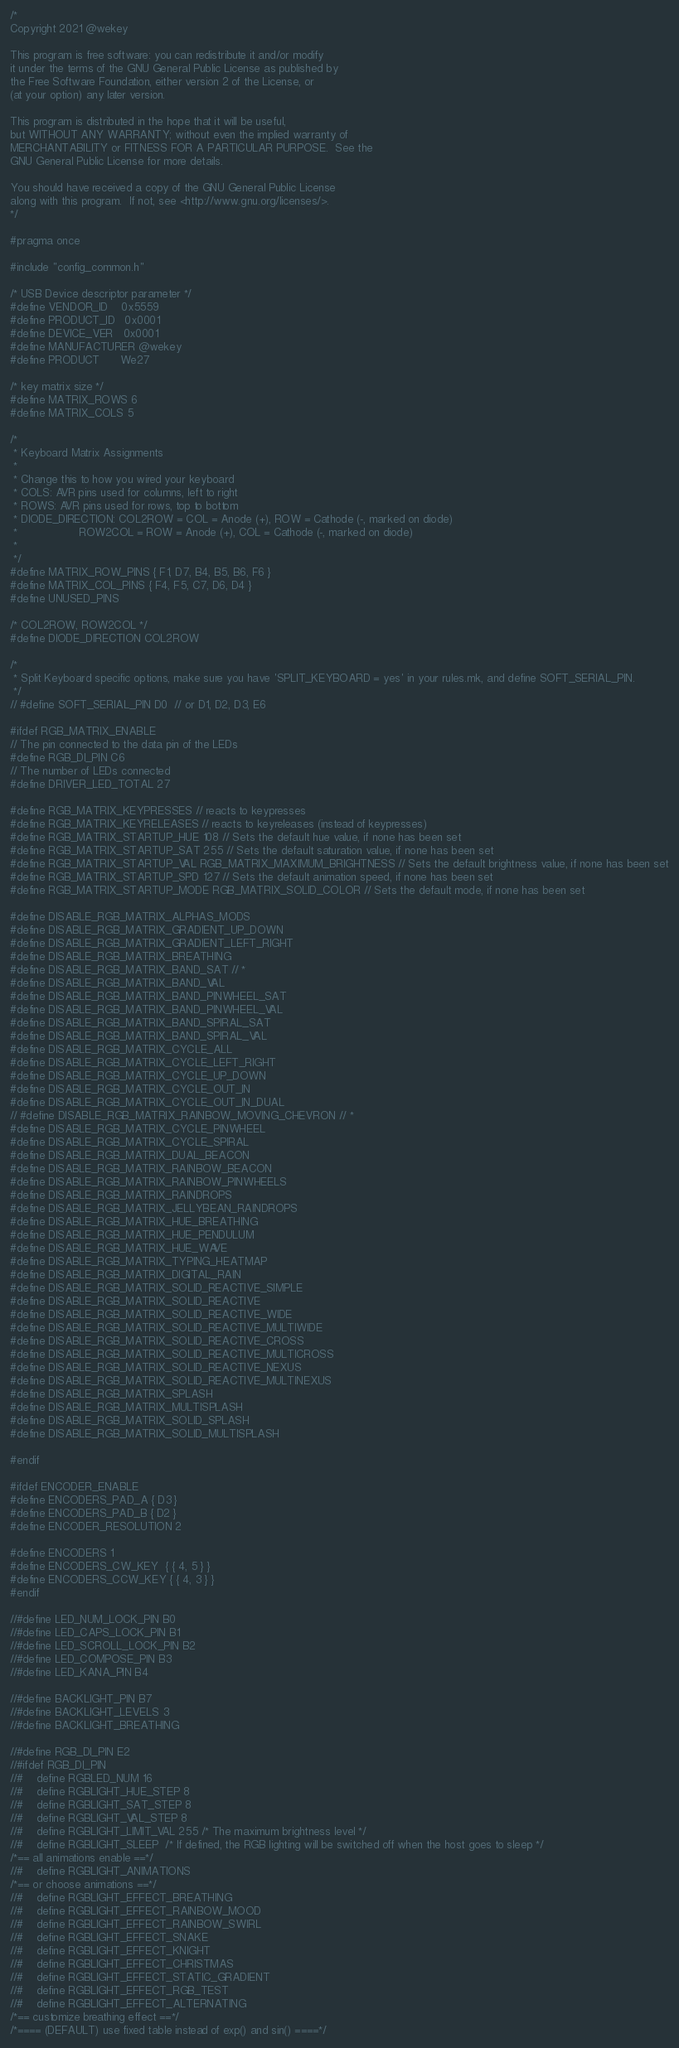<code> <loc_0><loc_0><loc_500><loc_500><_C_>/*
Copyright 2021 @wekey

This program is free software: you can redistribute it and/or modify
it under the terms of the GNU General Public License as published by
the Free Software Foundation, either version 2 of the License, or
(at your option) any later version.

This program is distributed in the hope that it will be useful,
but WITHOUT ANY WARRANTY; without even the implied warranty of
MERCHANTABILITY or FITNESS FOR A PARTICULAR PURPOSE.  See the
GNU General Public License for more details.

You should have received a copy of the GNU General Public License
along with this program.  If not, see <http://www.gnu.org/licenses/>.
*/

#pragma once

#include "config_common.h"

/* USB Device descriptor parameter */
#define VENDOR_ID    0x5559
#define PRODUCT_ID   0x0001
#define DEVICE_VER   0x0001
#define MANUFACTURER @wekey
#define PRODUCT      We27

/* key matrix size */
#define MATRIX_ROWS 6
#define MATRIX_COLS 5

/*
 * Keyboard Matrix Assignments
 *
 * Change this to how you wired your keyboard
 * COLS: AVR pins used for columns, left to right
 * ROWS: AVR pins used for rows, top to bottom
 * DIODE_DIRECTION: COL2ROW = COL = Anode (+), ROW = Cathode (-, marked on diode)
 *                  ROW2COL = ROW = Anode (+), COL = Cathode (-, marked on diode)
 *
 */
#define MATRIX_ROW_PINS { F1, D7, B4, B5, B6, F6 }
#define MATRIX_COL_PINS { F4, F5, C7, D6, D4 }
#define UNUSED_PINS

/* COL2ROW, ROW2COL */
#define DIODE_DIRECTION COL2ROW

/*
 * Split Keyboard specific options, make sure you have 'SPLIT_KEYBOARD = yes' in your rules.mk, and define SOFT_SERIAL_PIN.
 */
// #define SOFT_SERIAL_PIN D0  // or D1, D2, D3, E6

#ifdef RGB_MATRIX_ENABLE
// The pin connected to the data pin of the LEDs
#define RGB_DI_PIN C6
// The number of LEDs connected
#define DRIVER_LED_TOTAL 27

#define RGB_MATRIX_KEYPRESSES // reacts to keypresses
#define RGB_MATRIX_KEYRELEASES // reacts to keyreleases (instead of keypresses)
#define RGB_MATRIX_STARTUP_HUE 108 // Sets the default hue value, if none has been set
#define RGB_MATRIX_STARTUP_SAT 255 // Sets the default saturation value, if none has been set
#define RGB_MATRIX_STARTUP_VAL RGB_MATRIX_MAXIMUM_BRIGHTNESS // Sets the default brightness value, if none has been set
#define RGB_MATRIX_STARTUP_SPD 127 // Sets the default animation speed, if none has been set
#define RGB_MATRIX_STARTUP_MODE RGB_MATRIX_SOLID_COLOR // Sets the default mode, if none has been set

#define DISABLE_RGB_MATRIX_ALPHAS_MODS
#define DISABLE_RGB_MATRIX_GRADIENT_UP_DOWN
#define DISABLE_RGB_MATRIX_GRADIENT_LEFT_RIGHT
#define DISABLE_RGB_MATRIX_BREATHING
#define DISABLE_RGB_MATRIX_BAND_SAT // *
#define DISABLE_RGB_MATRIX_BAND_VAL
#define DISABLE_RGB_MATRIX_BAND_PINWHEEL_SAT
#define DISABLE_RGB_MATRIX_BAND_PINWHEEL_VAL
#define DISABLE_RGB_MATRIX_BAND_SPIRAL_SAT
#define DISABLE_RGB_MATRIX_BAND_SPIRAL_VAL
#define DISABLE_RGB_MATRIX_CYCLE_ALL
#define DISABLE_RGB_MATRIX_CYCLE_LEFT_RIGHT
#define DISABLE_RGB_MATRIX_CYCLE_UP_DOWN
#define DISABLE_RGB_MATRIX_CYCLE_OUT_IN
#define DISABLE_RGB_MATRIX_CYCLE_OUT_IN_DUAL
// #define DISABLE_RGB_MATRIX_RAINBOW_MOVING_CHEVRON // *
#define DISABLE_RGB_MATRIX_CYCLE_PINWHEEL
#define DISABLE_RGB_MATRIX_CYCLE_SPIRAL
#define DISABLE_RGB_MATRIX_DUAL_BEACON
#define DISABLE_RGB_MATRIX_RAINBOW_BEACON
#define DISABLE_RGB_MATRIX_RAINBOW_PINWHEELS
#define DISABLE_RGB_MATRIX_RAINDROPS
#define DISABLE_RGB_MATRIX_JELLYBEAN_RAINDROPS
#define DISABLE_RGB_MATRIX_HUE_BREATHING
#define DISABLE_RGB_MATRIX_HUE_PENDULUM
#define DISABLE_RGB_MATRIX_HUE_WAVE
#define DISABLE_RGB_MATRIX_TYPING_HEATMAP
#define DISABLE_RGB_MATRIX_DIGITAL_RAIN
#define DISABLE_RGB_MATRIX_SOLID_REACTIVE_SIMPLE
#define DISABLE_RGB_MATRIX_SOLID_REACTIVE
#define DISABLE_RGB_MATRIX_SOLID_REACTIVE_WIDE
#define DISABLE_RGB_MATRIX_SOLID_REACTIVE_MULTIWIDE
#define DISABLE_RGB_MATRIX_SOLID_REACTIVE_CROSS
#define DISABLE_RGB_MATRIX_SOLID_REACTIVE_MULTICROSS
#define DISABLE_RGB_MATRIX_SOLID_REACTIVE_NEXUS
#define DISABLE_RGB_MATRIX_SOLID_REACTIVE_MULTINEXUS
#define DISABLE_RGB_MATRIX_SPLASH
#define DISABLE_RGB_MATRIX_MULTISPLASH
#define DISABLE_RGB_MATRIX_SOLID_SPLASH
#define DISABLE_RGB_MATRIX_SOLID_MULTISPLASH

#endif

#ifdef ENCODER_ENABLE
#define ENCODERS_PAD_A { D3 }
#define ENCODERS_PAD_B { D2 } 
#define ENCODER_RESOLUTION 2

#define ENCODERS 1
#define ENCODERS_CW_KEY  { { 4, 5 } }
#define ENCODERS_CCW_KEY { { 4, 3 } }
#endif

//#define LED_NUM_LOCK_PIN B0
//#define LED_CAPS_LOCK_PIN B1
//#define LED_SCROLL_LOCK_PIN B2
//#define LED_COMPOSE_PIN B3
//#define LED_KANA_PIN B4

//#define BACKLIGHT_PIN B7
//#define BACKLIGHT_LEVELS 3
//#define BACKLIGHT_BREATHING

//#define RGB_DI_PIN E2
//#ifdef RGB_DI_PIN
//#    define RGBLED_NUM 16
//#    define RGBLIGHT_HUE_STEP 8
//#    define RGBLIGHT_SAT_STEP 8
//#    define RGBLIGHT_VAL_STEP 8
//#    define RGBLIGHT_LIMIT_VAL 255 /* The maximum brightness level */
//#    define RGBLIGHT_SLEEP  /* If defined, the RGB lighting will be switched off when the host goes to sleep */
/*== all animations enable ==*/
//#    define RGBLIGHT_ANIMATIONS
/*== or choose animations ==*/
//#    define RGBLIGHT_EFFECT_BREATHING
//#    define RGBLIGHT_EFFECT_RAINBOW_MOOD
//#    define RGBLIGHT_EFFECT_RAINBOW_SWIRL
//#    define RGBLIGHT_EFFECT_SNAKE
//#    define RGBLIGHT_EFFECT_KNIGHT
//#    define RGBLIGHT_EFFECT_CHRISTMAS
//#    define RGBLIGHT_EFFECT_STATIC_GRADIENT
//#    define RGBLIGHT_EFFECT_RGB_TEST
//#    define RGBLIGHT_EFFECT_ALTERNATING
/*== customize breathing effect ==*/
/*==== (DEFAULT) use fixed table instead of exp() and sin() ====*/</code> 